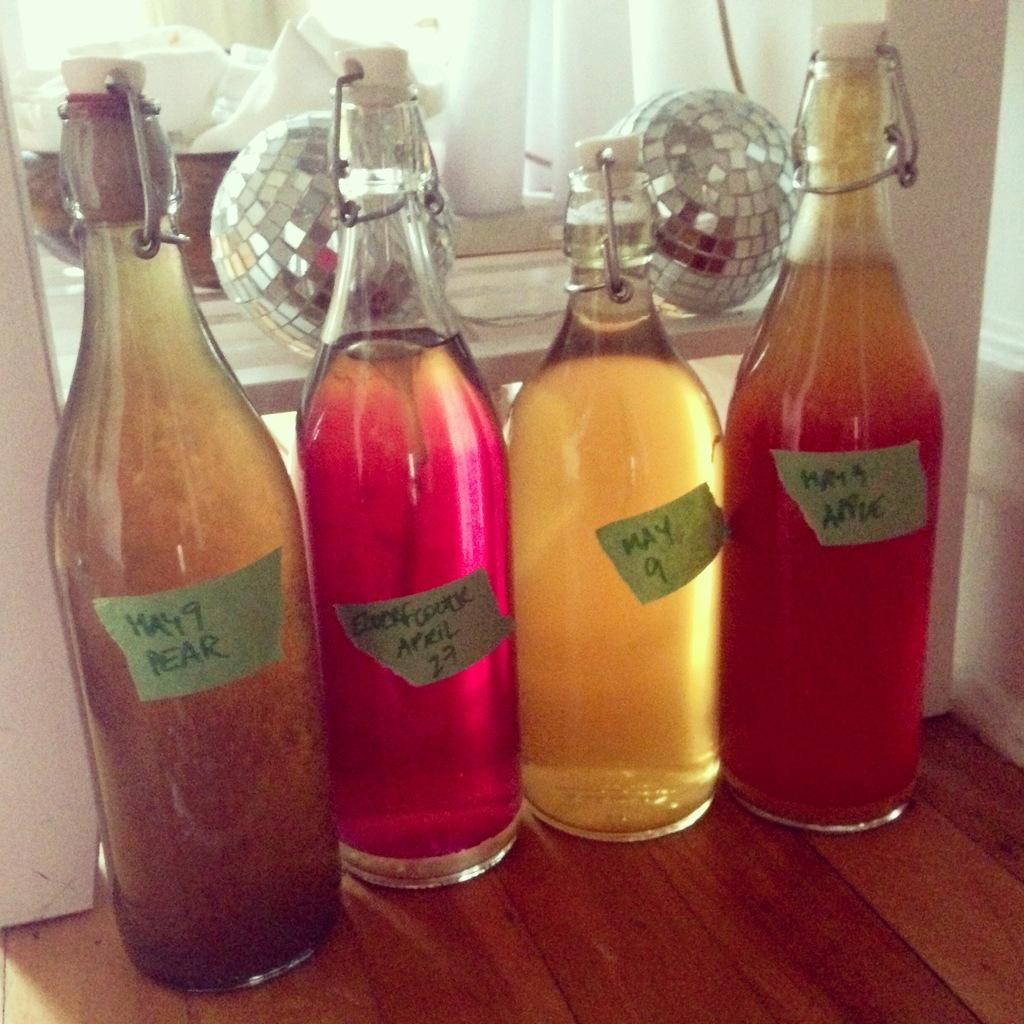<image>
Provide a brief description of the given image. the word May is on some of the bottles 